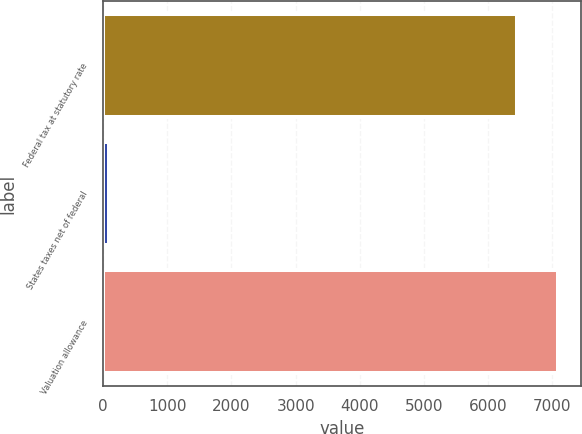Convert chart to OTSL. <chart><loc_0><loc_0><loc_500><loc_500><bar_chart><fcel>Federal tax at statutory rate<fcel>States taxes net of federal<fcel>Valuation allowance<nl><fcel>6447<fcel>91<fcel>7091.7<nl></chart> 